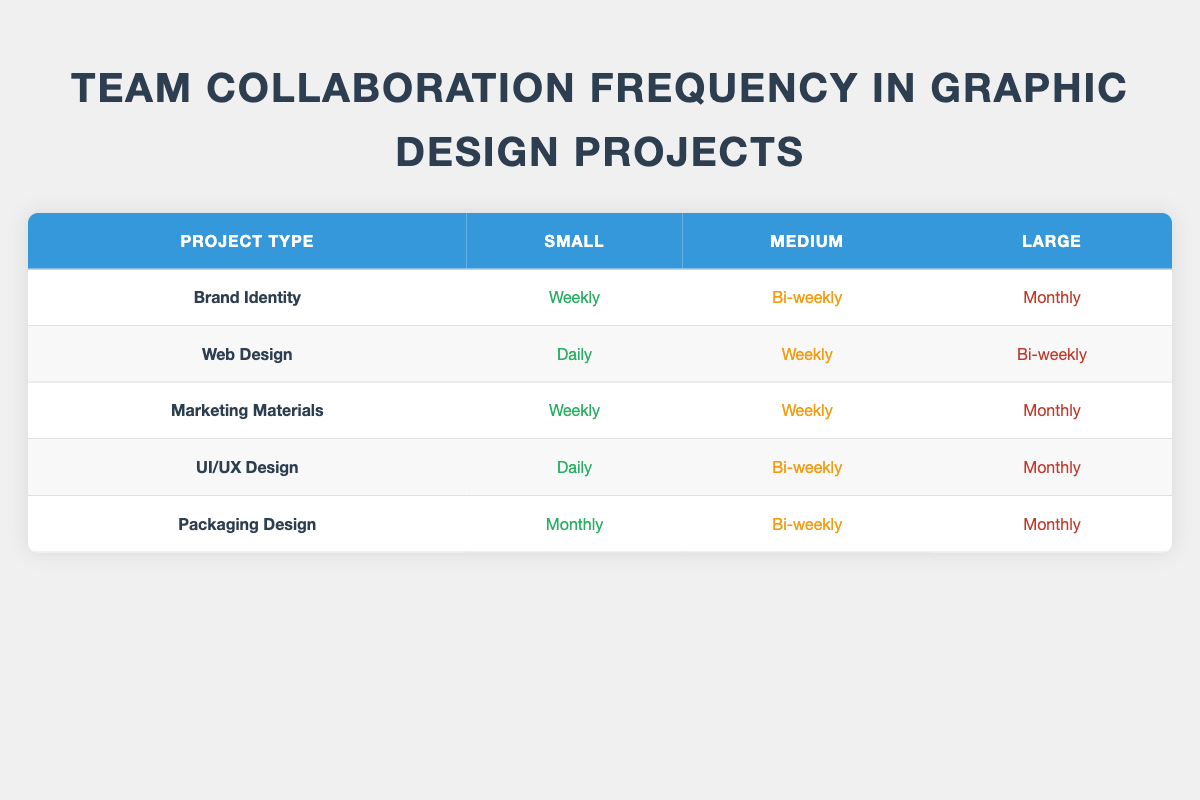What is the collaboration frequency for Small Brand Identity projects? The table shows that for Small Brand Identity projects, the collaboration frequency is listed as "Weekly".
Answer: Weekly How often do teams collaborate on Large Packaging Design projects? According to the table, Large Packaging Design projects have a collaboration frequency of "Monthly".
Answer: Monthly Is there a project type that requires daily collaboration? Yes, the table indicates that "Web Design" and "UI/UX Design" both have "Daily" collaboration frequency for Small projects.
Answer: Yes Which project type has the highest collaboration frequency for Medium projects? For Medium projects, "Marketing Materials" and "Web Design" both have "Weekly" collaboration frequency, which is the highest compared to other types for Medium projects.
Answer: Marketing Materials and Web Design If we combine the frequencies of collaboration for Large projects, what frequency has the most occurrences? The frequencies for Large projects are: "Monthly" for Brand Identity, Marketing Materials, UI/UX Design, and Packaging Design, and "Bi-weekly" for Web Design. The frequency "Monthly" occurs 4 times, while "Bi-weekly" occurs 1 time. Thus, "Monthly" has more occurrences.
Answer: Monthly How does the collaboration frequency change for Brand Identity projects from Small to Large size? For Brand Identity, the frequency changes from "Weekly" for Small, to "Bi-weekly" for Medium, and then to "Monthly" for Large projects, showing a decrease in frequency as the project size increases.
Answer: Decreases from Weekly to Monthly Are there any project types that require the same collaboration frequency for both Small and Medium sizes? Yes, "Marketing Materials" has "Weekly" collaboration frequency for both Small and Medium sizes, which is the same.
Answer: Yes Which project type has the lowest collaboration frequency for Small size? The table indicates that "Packaging Design" has "Monthly" collaboration frequency for Small projects, which is the lowest compared to others.
Answer: Monthly 